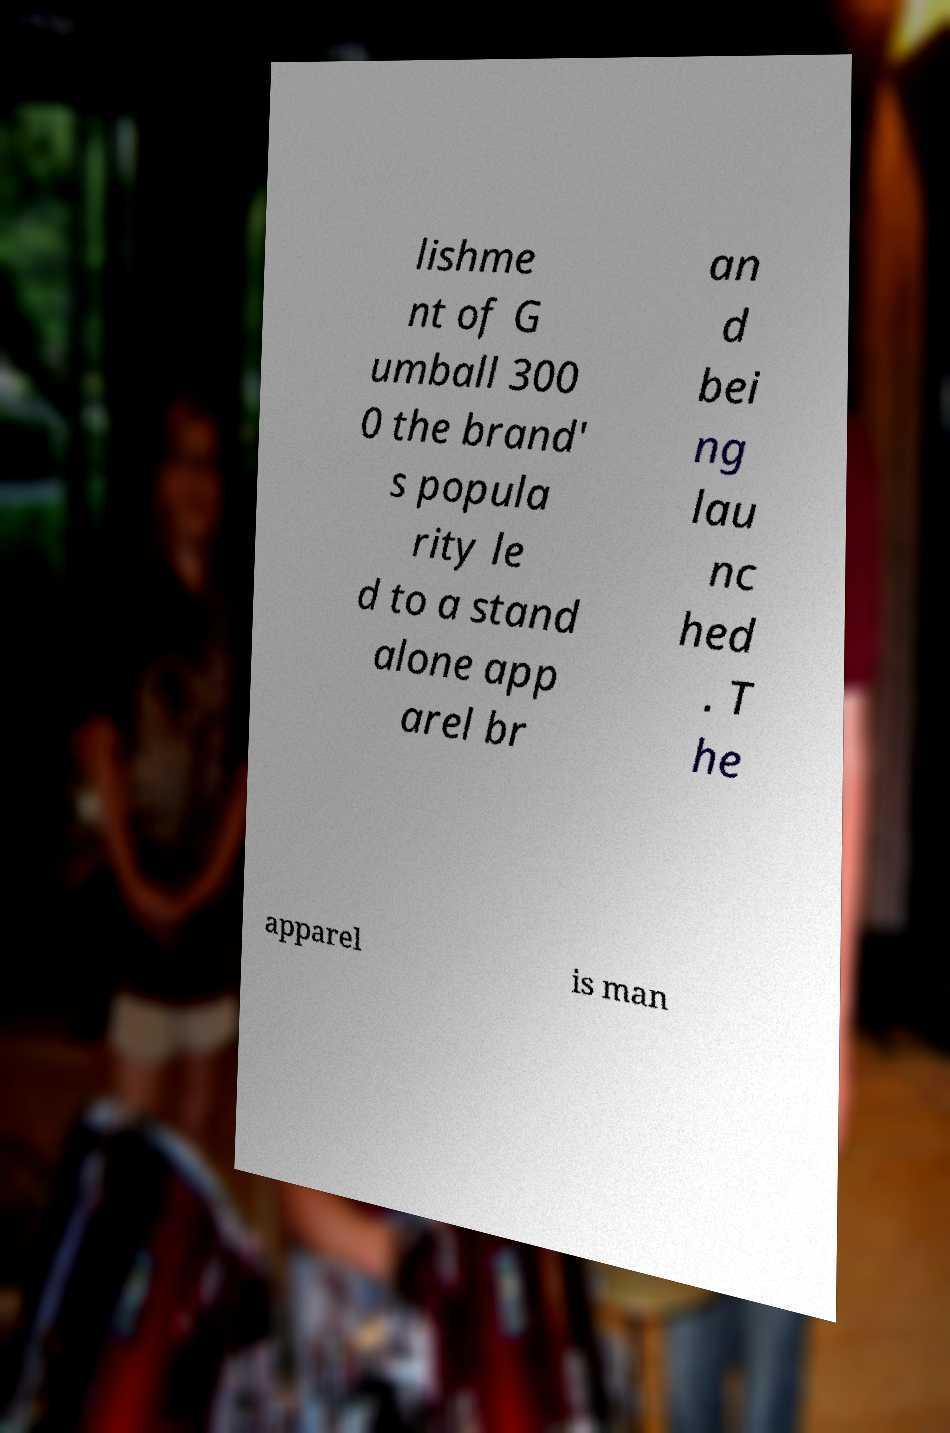Can you read and provide the text displayed in the image?This photo seems to have some interesting text. Can you extract and type it out for me? lishme nt of G umball 300 0 the brand' s popula rity le d to a stand alone app arel br an d bei ng lau nc hed . T he apparel is man 